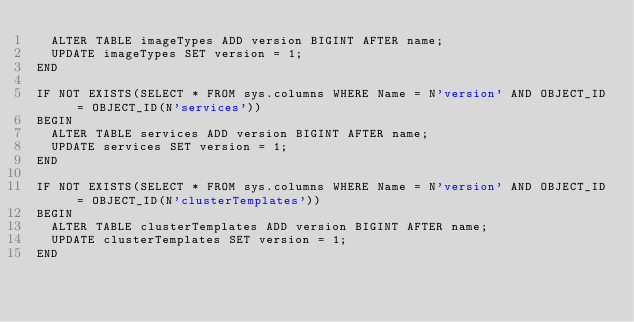Convert code to text. <code><loc_0><loc_0><loc_500><loc_500><_SQL_>  ALTER TABLE imageTypes ADD version BIGINT AFTER name;
  UPDATE imageTypes SET version = 1;
END

IF NOT EXISTS(SELECT * FROM sys.columns WHERE Name = N'version' AND OBJECT_ID = OBJECT_ID(N'services'))
BEGIN
  ALTER TABLE services ADD version BIGINT AFTER name;
  UPDATE services SET version = 1;
END

IF NOT EXISTS(SELECT * FROM sys.columns WHERE Name = N'version' AND OBJECT_ID = OBJECT_ID(N'clusterTemplates'))
BEGIN
  ALTER TABLE clusterTemplates ADD version BIGINT AFTER name;
  UPDATE clusterTemplates SET version = 1;
END
</code> 